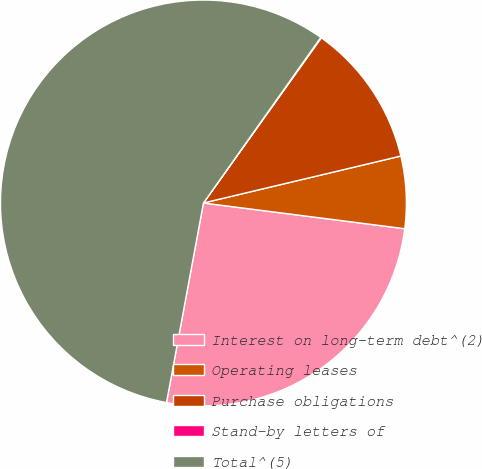<chart> <loc_0><loc_0><loc_500><loc_500><pie_chart><fcel>Interest on long-term debt^(2)<fcel>Operating leases<fcel>Purchase obligations<fcel>Stand-by letters of<fcel>Total^(5)<nl><fcel>25.89%<fcel>5.74%<fcel>11.42%<fcel>0.05%<fcel>56.9%<nl></chart> 